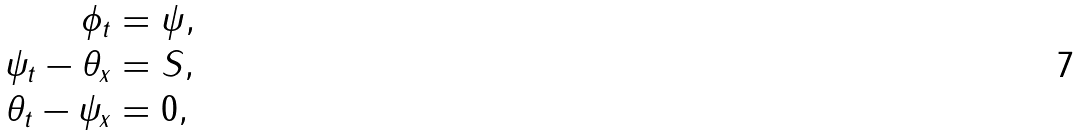Convert formula to latex. <formula><loc_0><loc_0><loc_500><loc_500>\phi _ { t } & = \psi , \\ \psi _ { t } - \theta _ { x } & = S , \\ \theta _ { t } - \psi _ { x } & = 0 , \\</formula> 